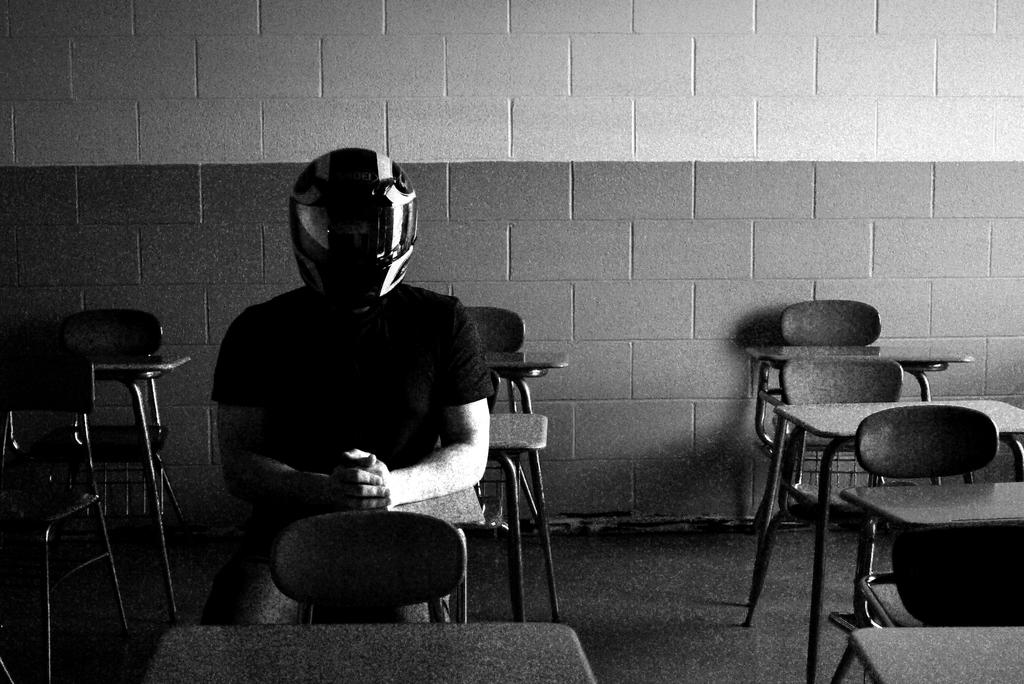Who or what is in the image? There is a person in the image. What is the person doing in the image? The person is sitting on chairs. What objects are in front of the person? Tables are in front of the person. What is the person wearing on their head? The person is wearing a helmet. What type of food is the person biting in the image? There is no food present in the image, and the person is not biting anything. 